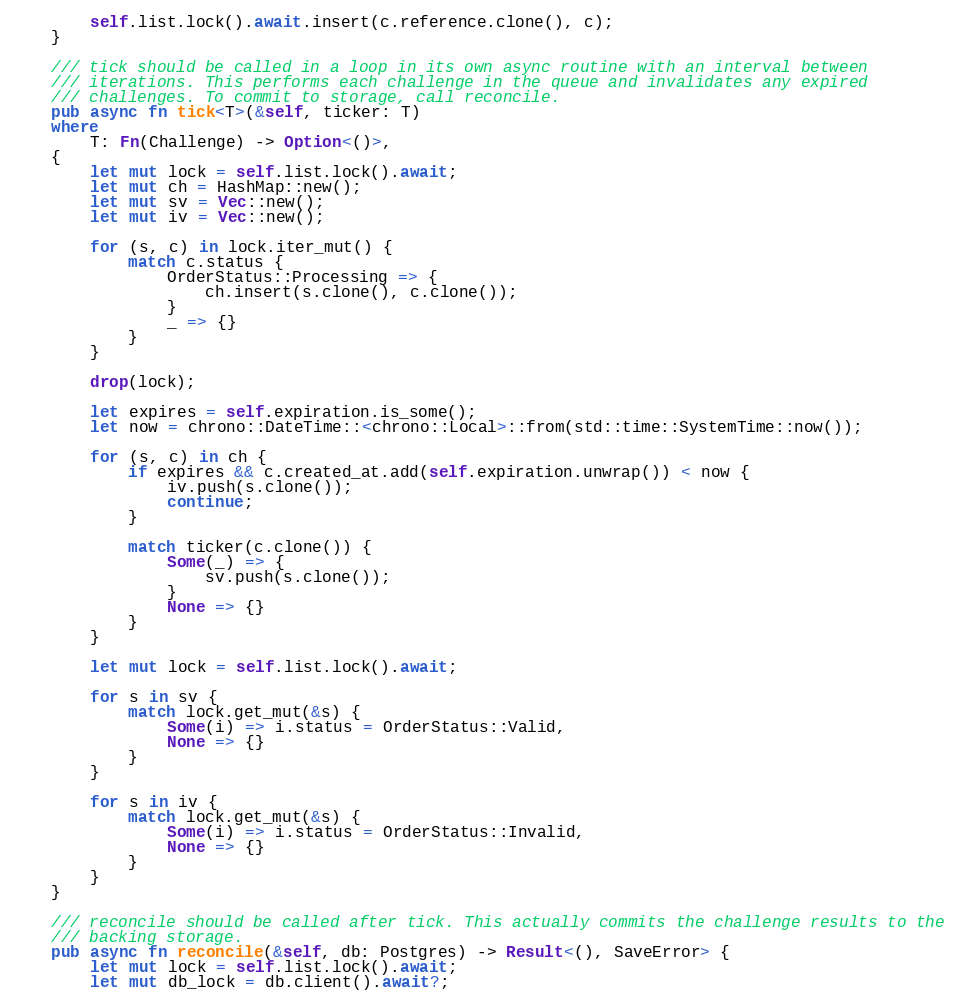<code> <loc_0><loc_0><loc_500><loc_500><_Rust_>        self.list.lock().await.insert(c.reference.clone(), c);
    }

    /// tick should be called in a loop in its own async routine with an interval between
    /// iterations. This performs each challenge in the queue and invalidates any expired
    /// challenges. To commit to storage, call reconcile.
    pub async fn tick<T>(&self, ticker: T)
    where
        T: Fn(Challenge) -> Option<()>,
    {
        let mut lock = self.list.lock().await;
        let mut ch = HashMap::new();
        let mut sv = Vec::new();
        let mut iv = Vec::new();

        for (s, c) in lock.iter_mut() {
            match c.status {
                OrderStatus::Processing => {
                    ch.insert(s.clone(), c.clone());
                }
                _ => {}
            }
        }

        drop(lock);

        let expires = self.expiration.is_some();
        let now = chrono::DateTime::<chrono::Local>::from(std::time::SystemTime::now());

        for (s, c) in ch {
            if expires && c.created_at.add(self.expiration.unwrap()) < now {
                iv.push(s.clone());
                continue;
            }

            match ticker(c.clone()) {
                Some(_) => {
                    sv.push(s.clone());
                }
                None => {}
            }
        }

        let mut lock = self.list.lock().await;

        for s in sv {
            match lock.get_mut(&s) {
                Some(i) => i.status = OrderStatus::Valid,
                None => {}
            }
        }

        for s in iv {
            match lock.get_mut(&s) {
                Some(i) => i.status = OrderStatus::Invalid,
                None => {}
            }
        }
    }

    /// reconcile should be called after tick. This actually commits the challenge results to the
    /// backing storage.
    pub async fn reconcile(&self, db: Postgres) -> Result<(), SaveError> {
        let mut lock = self.list.lock().await;
        let mut db_lock = db.client().await?;</code> 